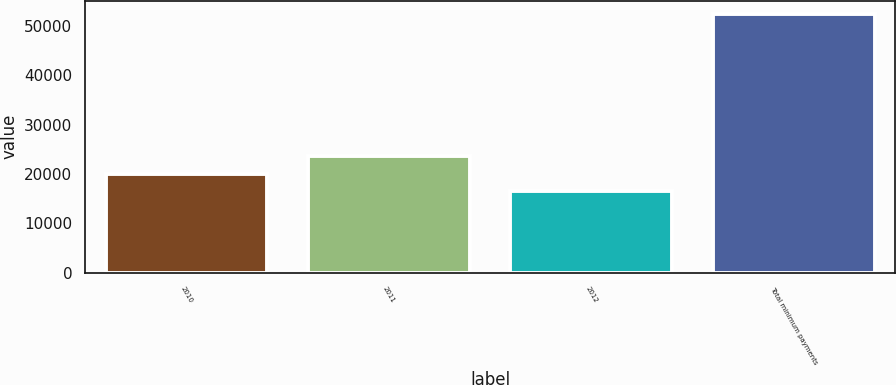<chart> <loc_0><loc_0><loc_500><loc_500><bar_chart><fcel>2010<fcel>2011<fcel>2012<fcel>Total minimum payments<nl><fcel>20100<fcel>23700<fcel>16500<fcel>52500<nl></chart> 